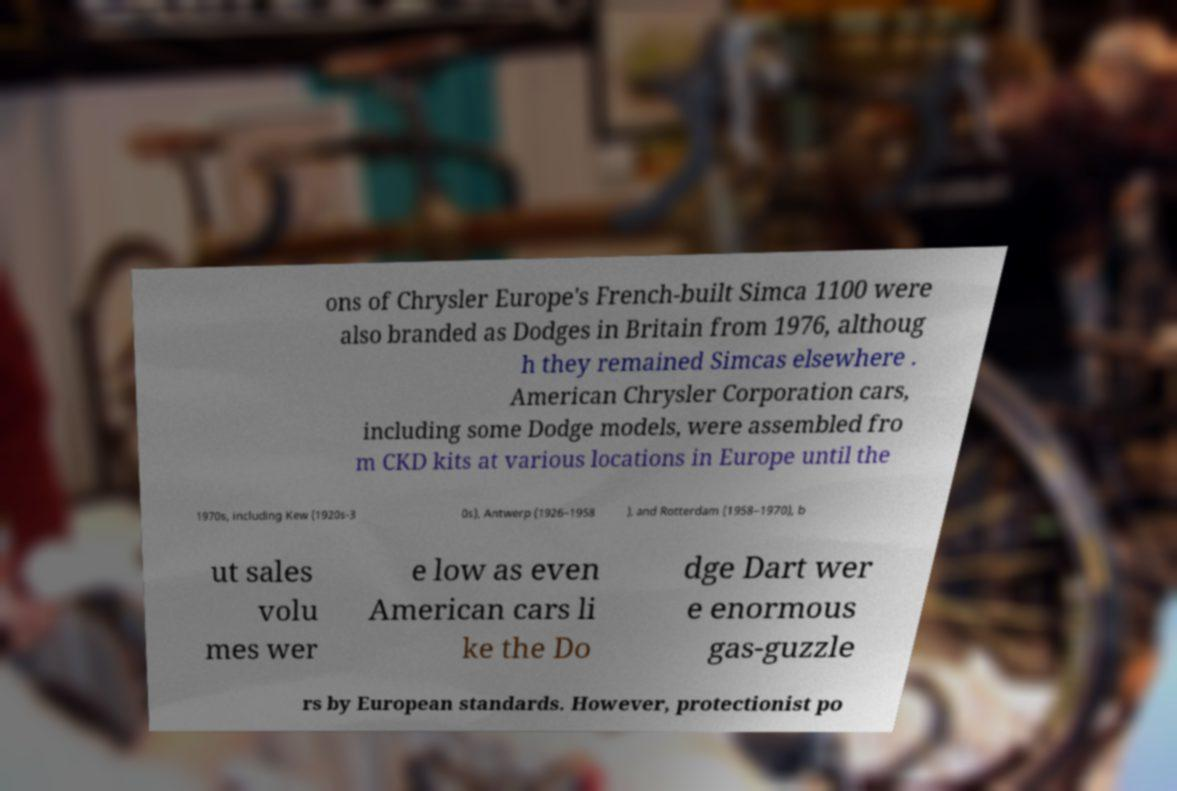Please read and relay the text visible in this image. What does it say? ons of Chrysler Europe's French-built Simca 1100 were also branded as Dodges in Britain from 1976, althoug h they remained Simcas elsewhere . American Chrysler Corporation cars, including some Dodge models, were assembled fro m CKD kits at various locations in Europe until the 1970s, including Kew (1920s-3 0s), Antwerp (1926–1958 ), and Rotterdam (1958–1970), b ut sales volu mes wer e low as even American cars li ke the Do dge Dart wer e enormous gas-guzzle rs by European standards. However, protectionist po 